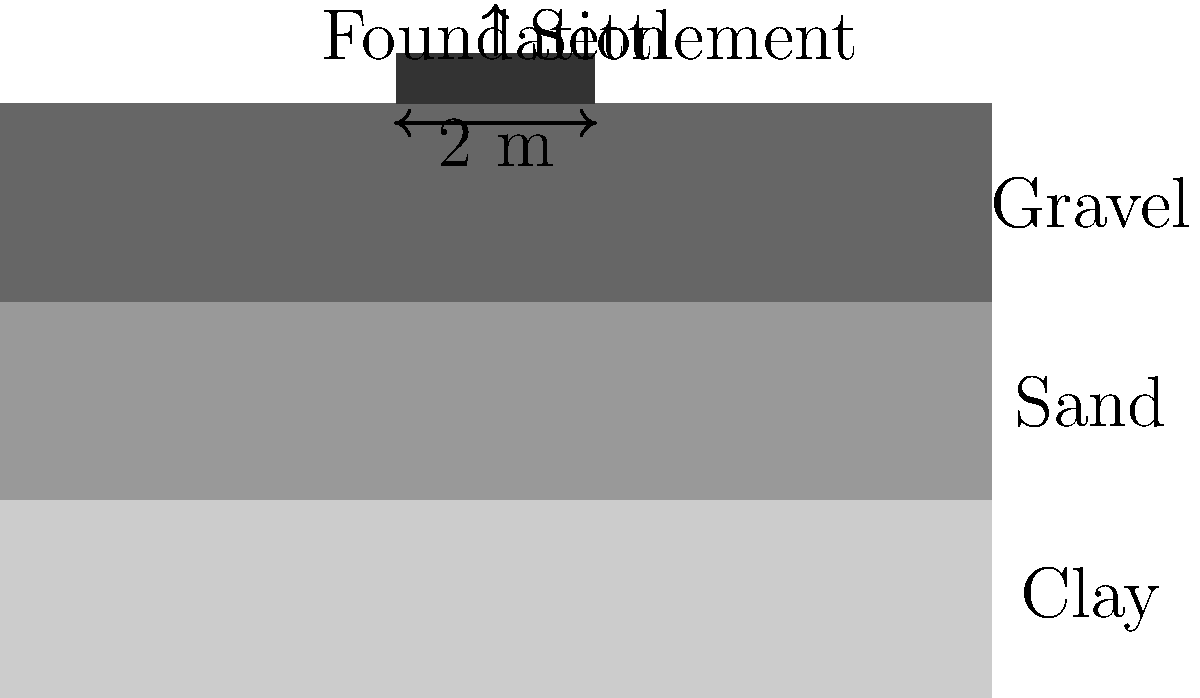As a rookie sales representative for a geotechnical engineering firm, you're tasked with explaining settlement estimation to a potential client. Given a 2-meter wide foundation resting on a layered soil profile (clay, sand, and gravel from bottom to top), each layer being 20 cm thick, estimate the total settlement. Assume the following:

1. Clay layer: Compression index ($C_c$) = 0.2, initial void ratio ($e_0$) = 0.9
2. Sand layer: Elastic modulus ($E_s$) = 30 MPa
3. Gravel layer: Elastic modulus ($E_s$) = 50 MPa
4. Applied pressure ($\Delta p$) = 200 kPa
5. Initial effective stress at the center of clay layer ($p_0$) = 30 kPa

What is the estimated total settlement (in mm) of the foundation? To estimate the total settlement, we need to calculate the settlement for each layer and sum them up. Let's go through this step-by-step:

1. Clay layer (using consolidation settlement equation):
   $S_c = H \frac{C_c}{1+e_0} \log_{10}(\frac{p_0 + \Delta p}{p_0})$
   $S_c = 0.2 \times \frac{0.2}{1+0.9} \log_{10}(\frac{30 + 200}{30})$
   $S_c = 0.021 \text{ m} = 21 \text{ mm}$

2. Sand layer (using elastic settlement equation):
   $S_e = \frac{\Delta p \times H}{E_s}$
   $S_e = \frac{200 \text{ kPa} \times 0.2 \text{ m}}{30,000 \text{ kPa}}$
   $S_e = 0.00133 \text{ m} = 1.33 \text{ mm}$

3. Gravel layer (using elastic settlement equation):
   $S_e = \frac{\Delta p \times H}{E_s}$
   $S_e = \frac{200 \text{ kPa} \times 0.2 \text{ m}}{50,000 \text{ kPa}}$
   $S_e = 0.0008 \text{ m} = 0.8 \text{ mm}$

4. Total settlement:
   $S_\text{total} = S_\text{clay} + S_\text{sand} + S_\text{gravel}$
   $S_\text{total} = 21 + 1.33 + 0.8 = 23.13 \text{ mm}$

Therefore, the estimated total settlement of the foundation is approximately 23.13 mm.
Answer: 23.13 mm 